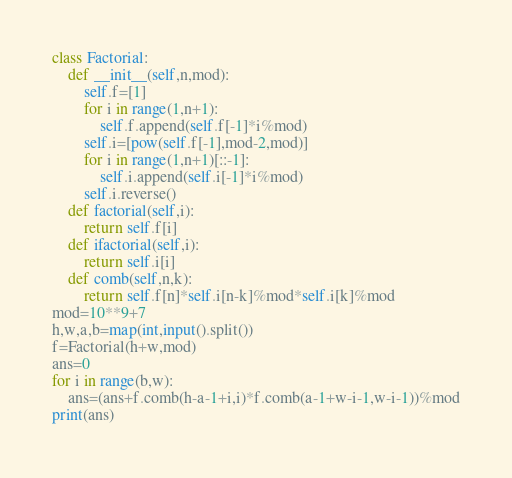Convert code to text. <code><loc_0><loc_0><loc_500><loc_500><_Python_>class Factorial:
    def __init__(self,n,mod):
        self.f=[1]
        for i in range(1,n+1):
            self.f.append(self.f[-1]*i%mod)
        self.i=[pow(self.f[-1],mod-2,mod)]
        for i in range(1,n+1)[::-1]:
            self.i.append(self.i[-1]*i%mod)
        self.i.reverse()
    def factorial(self,i):
        return self.f[i]
    def ifactorial(self,i):
        return self.i[i]
    def comb(self,n,k):
        return self.f[n]*self.i[n-k]%mod*self.i[k]%mod
mod=10**9+7
h,w,a,b=map(int,input().split())
f=Factorial(h+w,mod)
ans=0
for i in range(b,w):
    ans=(ans+f.comb(h-a-1+i,i)*f.comb(a-1+w-i-1,w-i-1))%mod
print(ans)</code> 